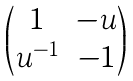Convert formula to latex. <formula><loc_0><loc_0><loc_500><loc_500>\begin{pmatrix} 1 & - u \\ u ^ { - 1 } & - 1 \end{pmatrix}</formula> 